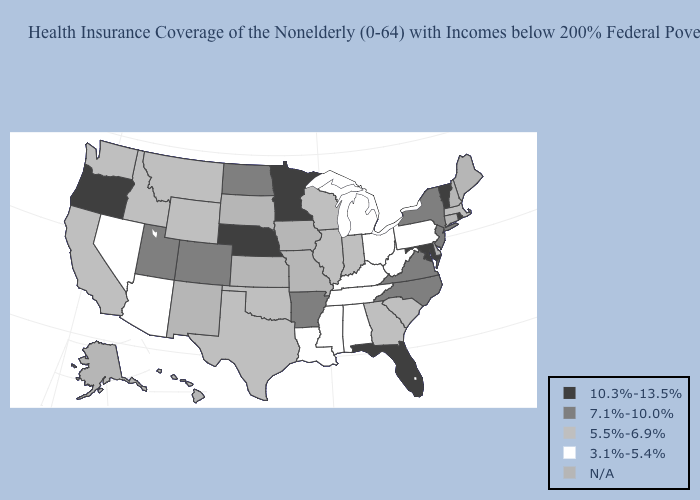Among the states that border South Carolina , which have the lowest value?
Short answer required. Georgia. What is the value of West Virginia?
Give a very brief answer. 3.1%-5.4%. What is the highest value in states that border Georgia?
Answer briefly. 10.3%-13.5%. Does Nebraska have the lowest value in the USA?
Concise answer only. No. Name the states that have a value in the range 10.3%-13.5%?
Give a very brief answer. Florida, Maryland, Minnesota, Nebraska, Oregon, Rhode Island, Vermont. What is the value of Illinois?
Keep it brief. 5.5%-6.9%. Among the states that border Arizona , which have the lowest value?
Keep it brief. Nevada. What is the value of Missouri?
Answer briefly. N/A. What is the value of Hawaii?
Be succinct. N/A. How many symbols are there in the legend?
Quick response, please. 5. What is the value of Indiana?
Write a very short answer. 5.5%-6.9%. How many symbols are there in the legend?
Write a very short answer. 5. 